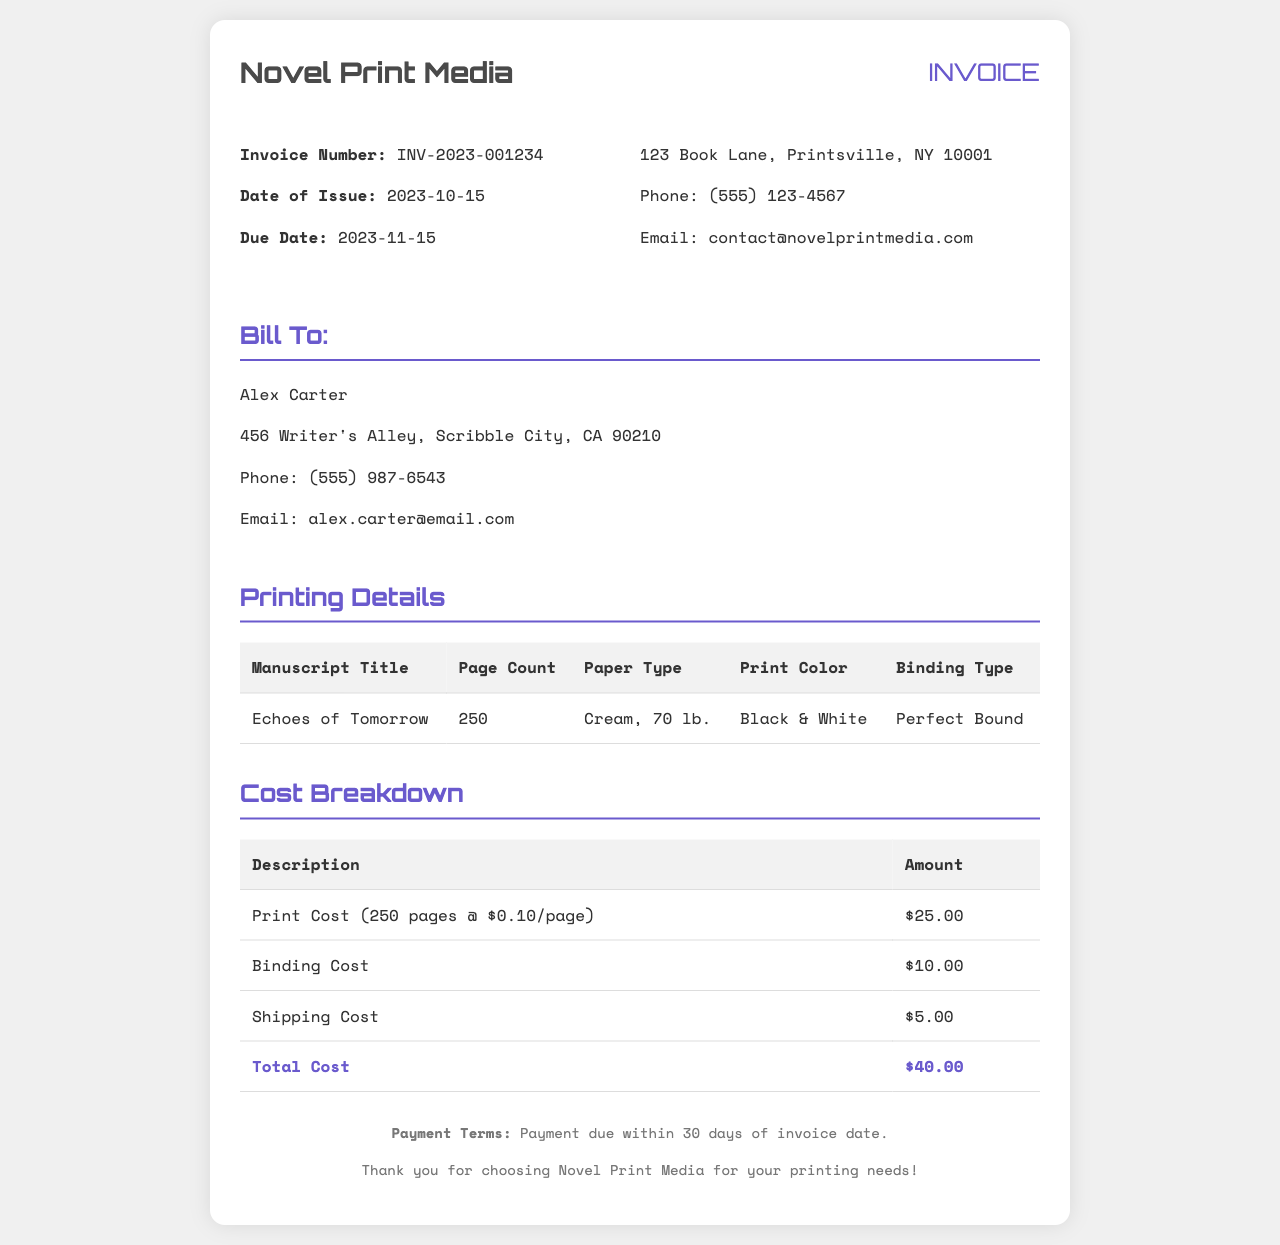What is the invoice number? The invoice number is specifically mentioned in the document as INV-2023-001234.
Answer: INV-2023-001234 What is the due date for the payment? The due date is listed as 2023-11-15 in the invoice details.
Answer: 2023-11-15 How many pages does the manuscript have? The page count for the manuscript titled "Echoes of Tomorrow" is 250 pages.
Answer: 250 What is the total cost for the printing service? The total amount listed in the cost breakdown is $40.00, encompassing all services rendered.
Answer: $40.00 What type of paper is used for printing? The document specifies the paper type as Cream, 70 lb.
Answer: Cream, 70 lb Who is the client for this invoice? The client's name is listed as Alex Carter in the billing section of the invoice.
Answer: Alex Carter What is the binding type mentioned in the printing details? The binding type specified for the manuscript is Perfect Bound.
Answer: Perfect Bound What is the print color for the manuscript? The document indicates that the print color is Black & White.
Answer: Black & White What is the shipping cost? The shipping cost itemized in the cost breakdown is $5.00.
Answer: $5.00 